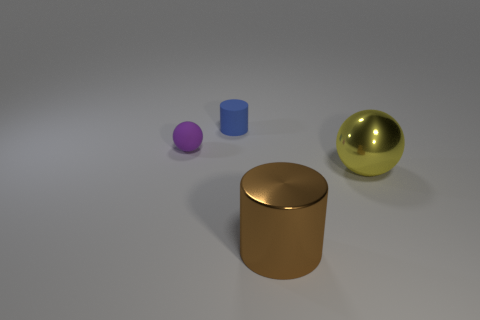Add 3 small gray rubber cubes. How many objects exist? 7 Add 4 large brown cylinders. How many large brown cylinders exist? 5 Subtract 0 gray cubes. How many objects are left? 4 Subtract all big cyan metal cylinders. Subtract all small blue cylinders. How many objects are left? 3 Add 2 large yellow balls. How many large yellow balls are left? 3 